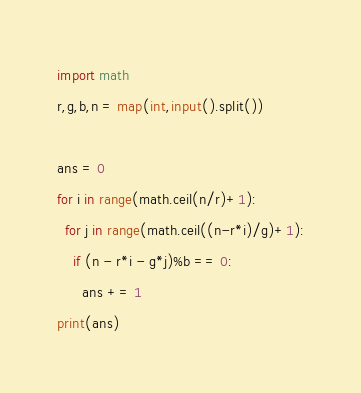Convert code to text. <code><loc_0><loc_0><loc_500><loc_500><_Python_>import math
r,g,b,n = map(int,input().split())
 
ans = 0
for i in range(math.ceil(n/r)+1):
  for j in range(math.ceil((n-r*i)/g)+1):
    if (n - r*i - g*j)%b == 0:
      ans += 1
print(ans)</code> 